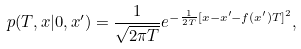Convert formula to latex. <formula><loc_0><loc_0><loc_500><loc_500>p ( T , x | 0 , x ^ { \prime } ) = \frac { 1 } { \sqrt { 2 \pi T } } e ^ { - \frac { 1 } { 2 T } [ x - x ^ { \prime } - f ( x ^ { \prime } ) T ] ^ { 2 } } ,</formula> 